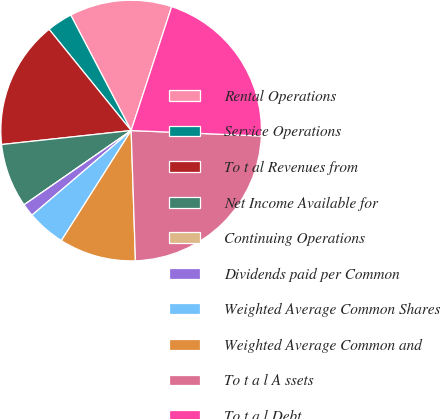<chart> <loc_0><loc_0><loc_500><loc_500><pie_chart><fcel>Rental Operations<fcel>Service Operations<fcel>To t al Revenues from<fcel>Net Income Available for<fcel>Continuing Operations<fcel>Dividends paid per Common<fcel>Weighted Average Common Shares<fcel>Weighted Average Common and<fcel>To t a l A ssets<fcel>To t a l Debt<nl><fcel>12.7%<fcel>3.17%<fcel>15.87%<fcel>7.94%<fcel>0.0%<fcel>1.59%<fcel>4.76%<fcel>9.52%<fcel>23.81%<fcel>20.63%<nl></chart> 